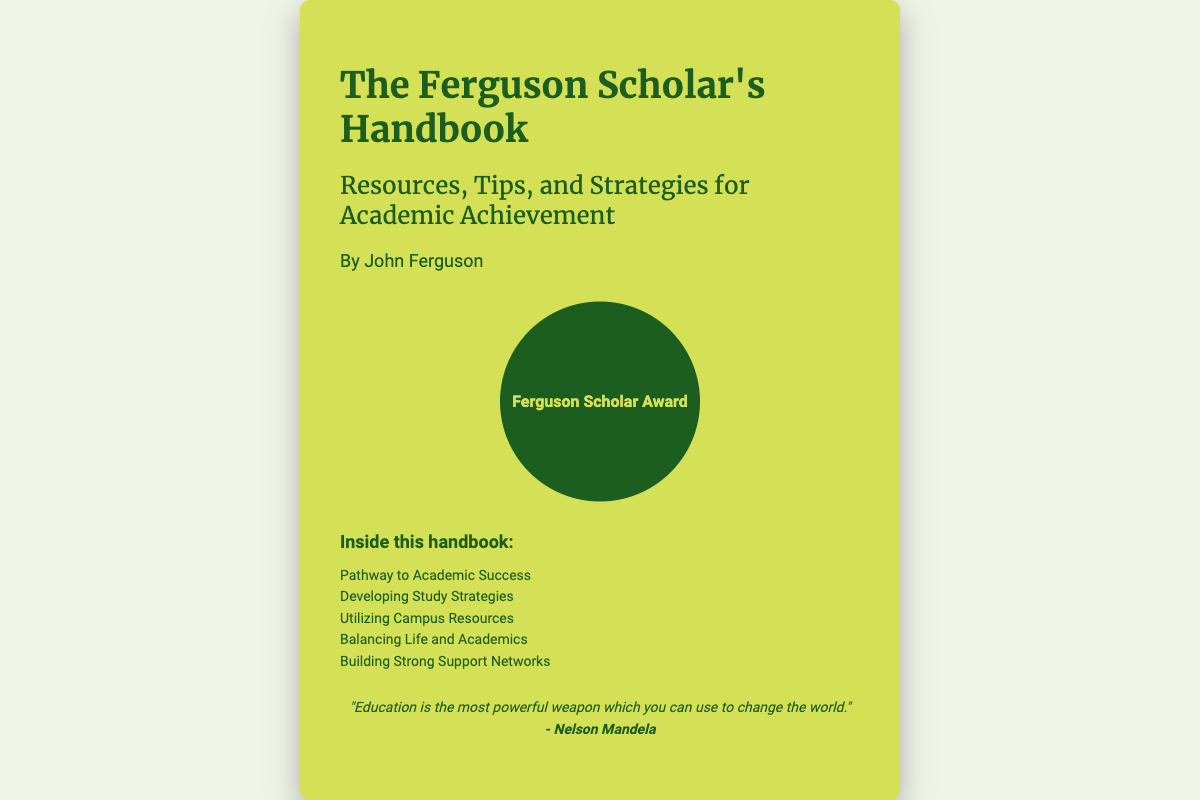What is the title of the book? The title appears prominently at the top of the book cover, indicating the subject matter and focus of the content.
Answer: The Ferguson Scholar's Handbook Who is the author of the book? The author's name can be found under the title on the cover, indicating who wrote the book.
Answer: John Ferguson What is the main theme of the handbook? The theme is suggested by the subtitle that describes the book's focus and purpose.
Answer: Resources, Tips, and Strategies for Academic Achievement How many chapters are listed in the handbook? The number of chapters can be counted from the list provided in the "Inside this handbook" section.
Answer: Five Which chapter focuses on study techniques? The specific chapter titles provide insight into the topics covered and the one related to study techniques is important for students.
Answer: Developing Study Strategies What is the quote attributed to? The quote is found at the bottom of the content area, reflecting a philosophy that relates to education.
Answer: Nelson Mandela What color is the book cover? The background color of the book cover is visible and is a key aspect of its design.
Answer: Green What is the circular image placeholder representing? The image placeholder is labeled, giving insight into its intended meaning or representation.
Answer: Ferguson Scholar Award 